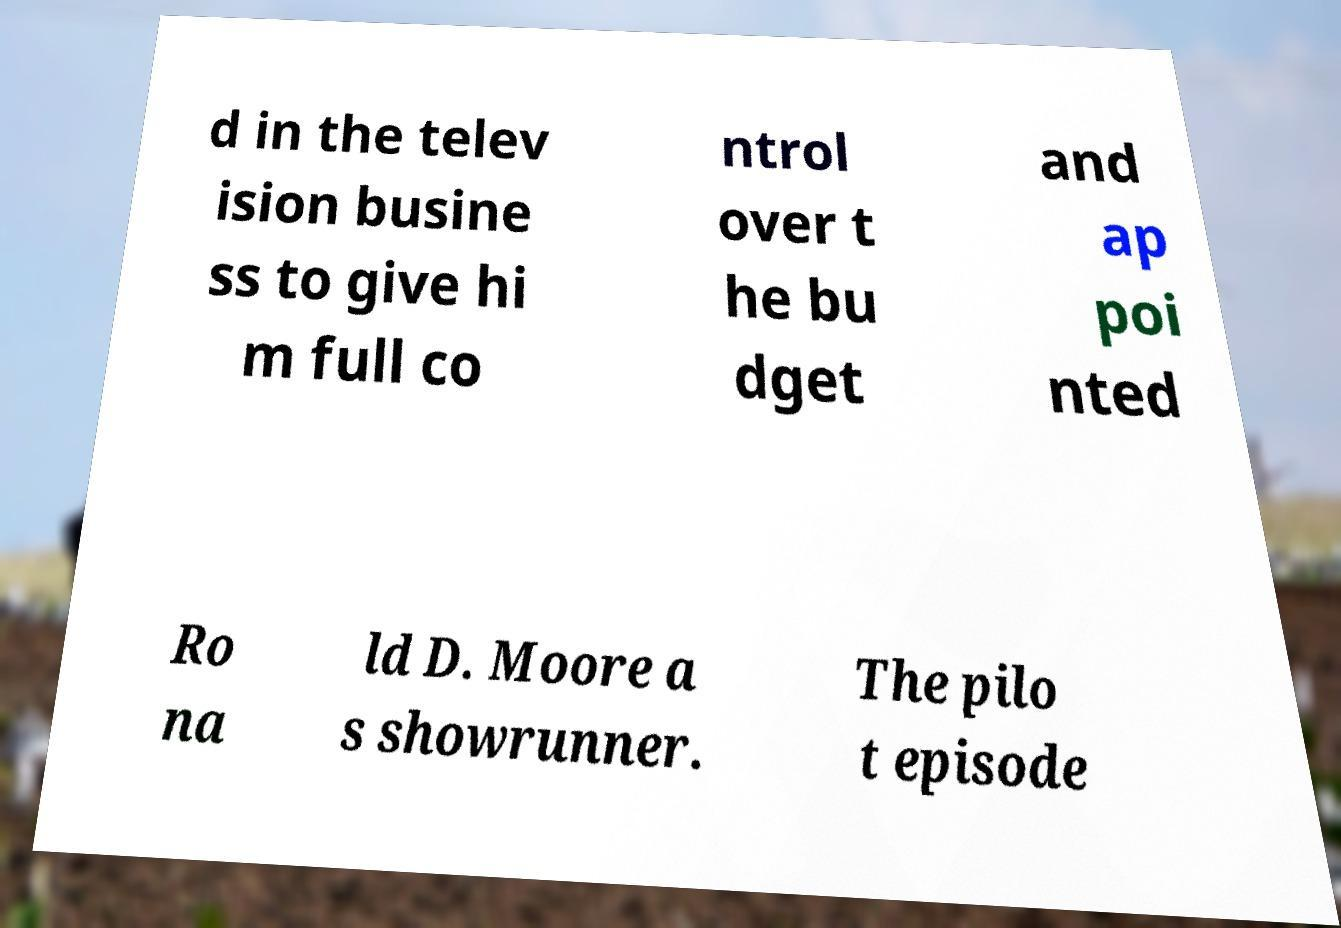Can you read and provide the text displayed in the image?This photo seems to have some interesting text. Can you extract and type it out for me? d in the telev ision busine ss to give hi m full co ntrol over t he bu dget and ap poi nted Ro na ld D. Moore a s showrunner. The pilo t episode 